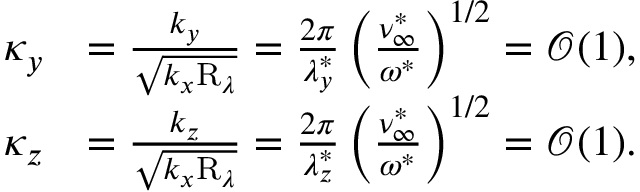Convert formula to latex. <formula><loc_0><loc_0><loc_500><loc_500>\begin{array} { r l } { \kappa _ { y } } & { = \frac { k _ { y } } { \sqrt { k _ { x } R _ { \lambda } } } = \frac { 2 \pi } { \lambda _ { y } ^ { \ast } } \left ( \frac { \nu _ { \infty } ^ { \ast } } { \omega ^ { \ast } } \right ) ^ { 1 / 2 } = \mathcal { O } ( 1 ) , } \\ { \kappa _ { z } } & { = \frac { k _ { z } } { \sqrt { k _ { x } R _ { \lambda } } } = \frac { 2 \pi } { \lambda _ { z } ^ { \ast } } \left ( \frac { \nu _ { \infty } ^ { \ast } } { \omega ^ { \ast } } \right ) ^ { 1 / 2 } = \mathcal { O } ( 1 ) . } \end{array}</formula> 